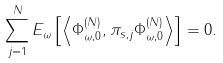<formula> <loc_0><loc_0><loc_500><loc_500>\sum _ { j = 1 } ^ { N } { E } _ { \omega } \left [ \left \langle \Phi _ { \omega , 0 } ^ { ( N ) } , \pi _ { s , j } \Phi _ { \omega , 0 } ^ { ( N ) } \right \rangle \right ] = 0 .</formula> 